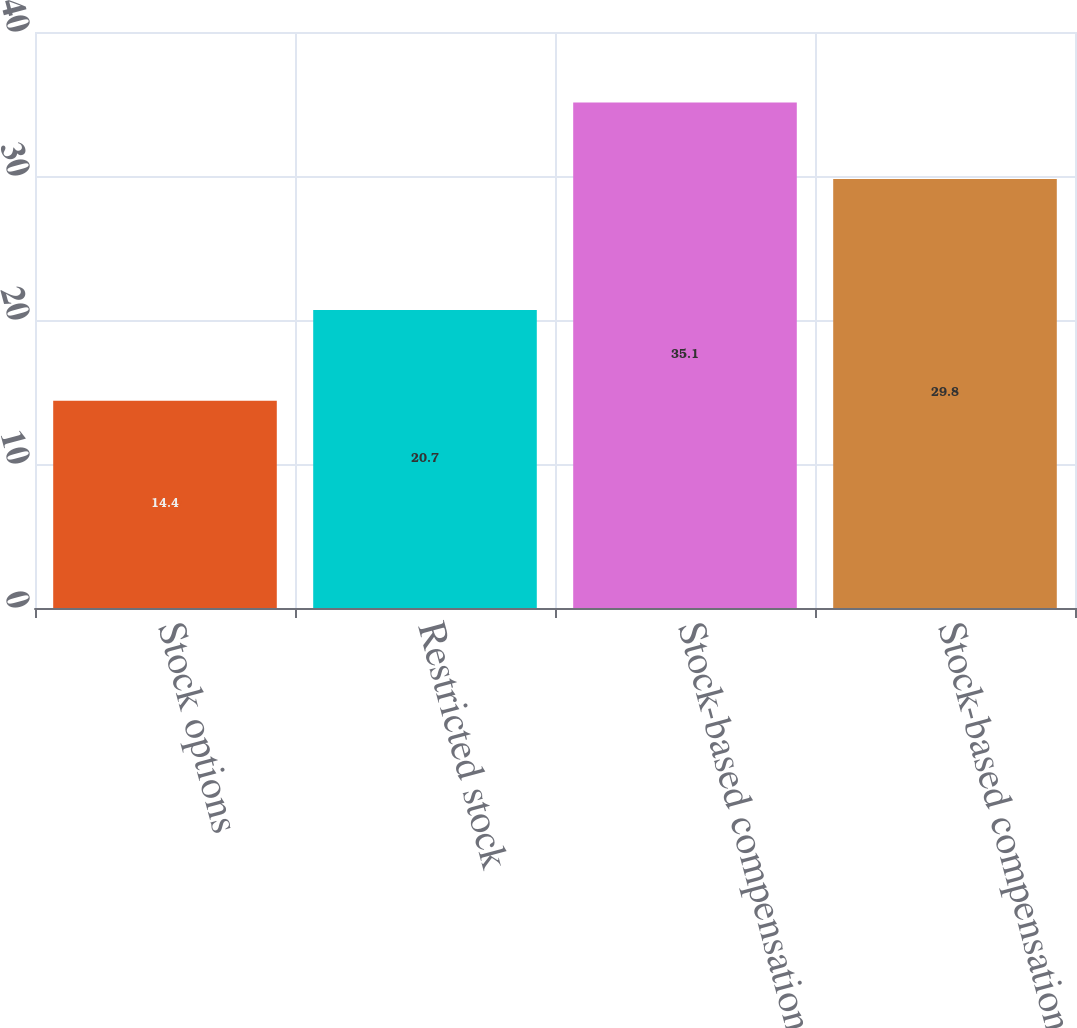Convert chart. <chart><loc_0><loc_0><loc_500><loc_500><bar_chart><fcel>Stock options<fcel>Restricted stock<fcel>Stock-based compensation<fcel>Stock-based compensation net<nl><fcel>14.4<fcel>20.7<fcel>35.1<fcel>29.8<nl></chart> 